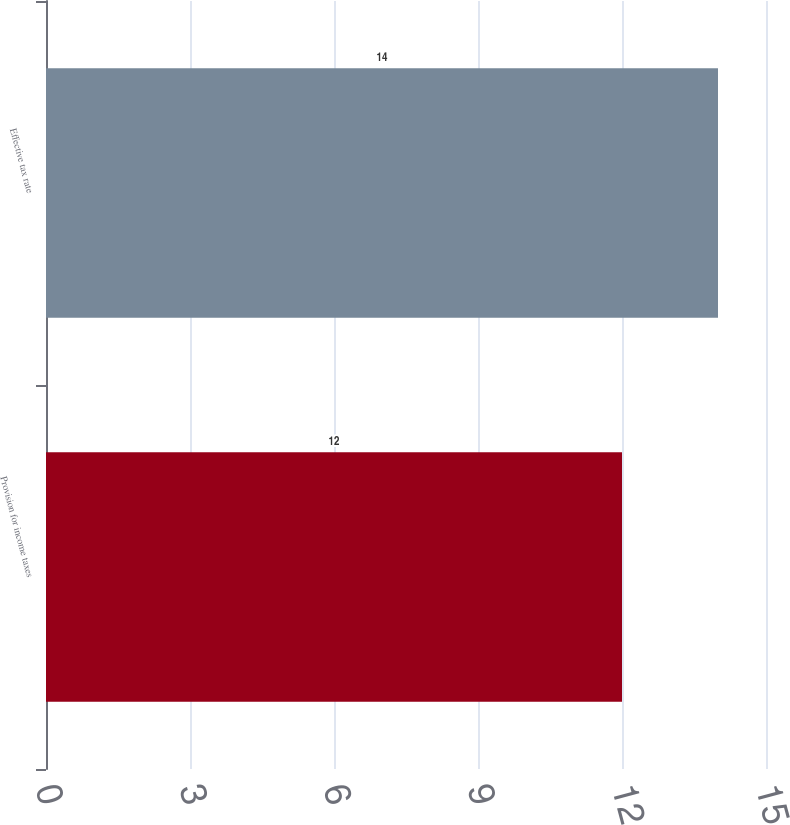<chart> <loc_0><loc_0><loc_500><loc_500><bar_chart><fcel>Provision for income taxes<fcel>Effective tax rate<nl><fcel>12<fcel>14<nl></chart> 